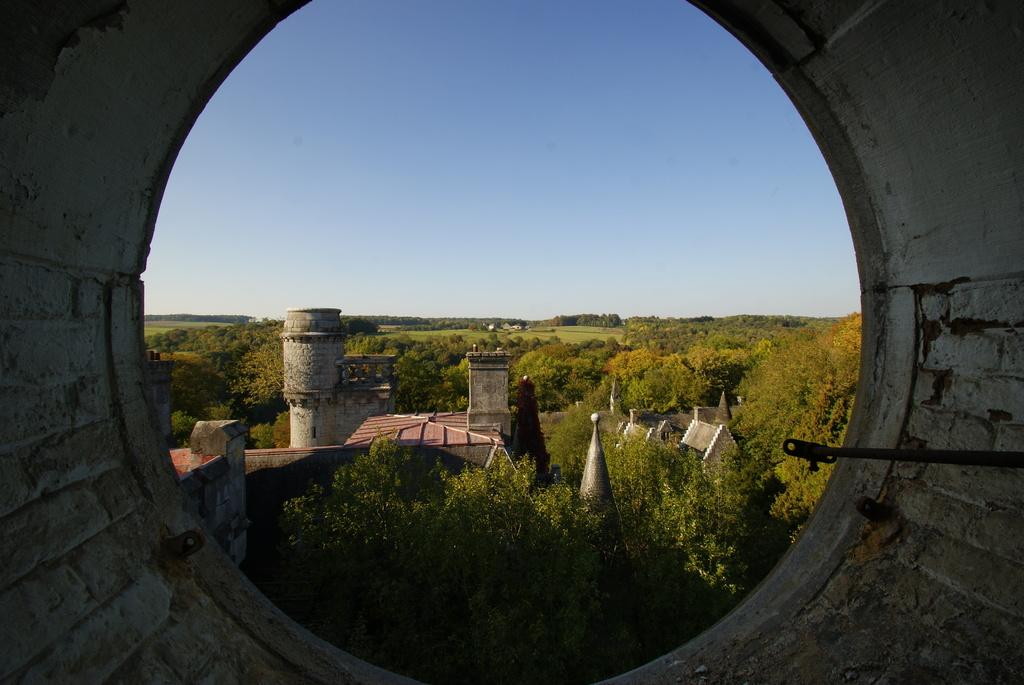Where was the image taken from? The image is taken from inside a tunnel. What can be seen through the tunnel? Buildings are visible through the tunnel. Are there any notable structures visible in the image? Yes, a castle is visible beside the buildings. What type of vegetation is present in the image? Trees are present in the image. What is visible at the top of the image? The sky is visible at the top of the image. What type of liquid is being sprayed by the hose in the image? There is no hose present in the image, so it is not possible to determine what type of liquid might be sprayed. 